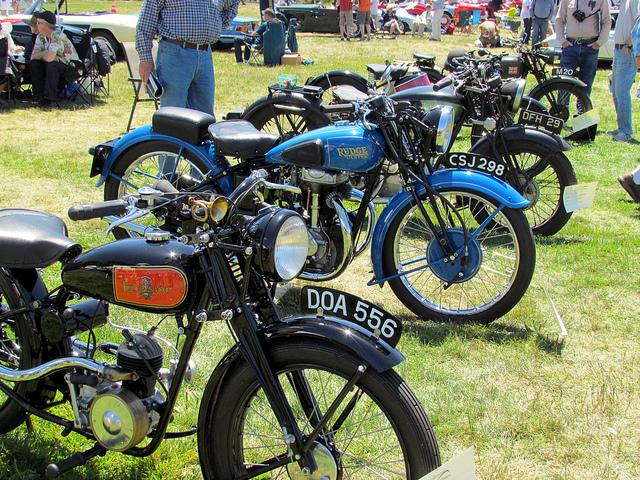Are these large motorcycles?
Concise answer only. No. Is this a parking lot?
Quick response, please. No. What is written on the bikes wheel?
Quick response, please. Doa 556. What color is the motorcycle labeled CSJ298?
Keep it brief. Blue. 